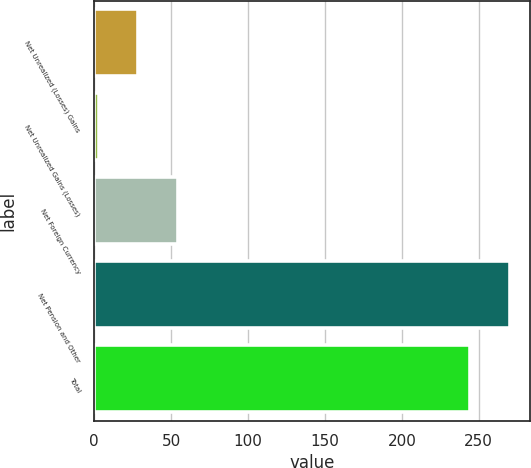Convert chart to OTSL. <chart><loc_0><loc_0><loc_500><loc_500><bar_chart><fcel>Net Unrealized (Losses) Gains<fcel>Net Unrealized Gains (Losses)<fcel>Net Foreign Currency<fcel>Net Pension and Other<fcel>Total<nl><fcel>28.64<fcel>2.9<fcel>54.38<fcel>270.04<fcel>244.3<nl></chart> 